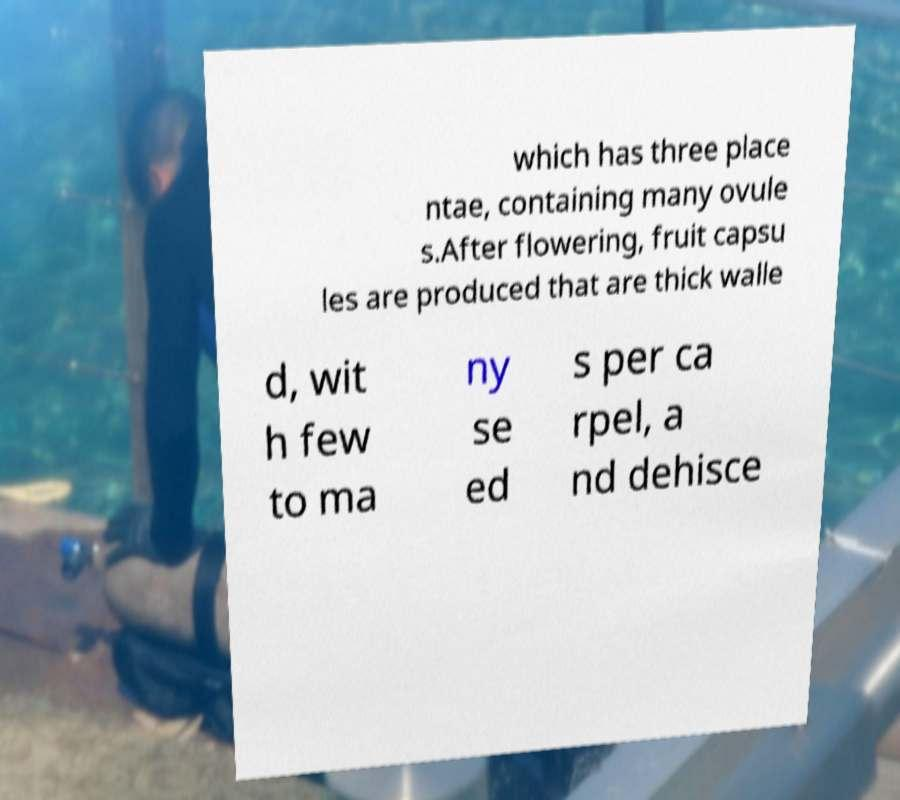Please read and relay the text visible in this image. What does it say? which has three place ntae, containing many ovule s.After flowering, fruit capsu les are produced that are thick walle d, wit h few to ma ny se ed s per ca rpel, a nd dehisce 